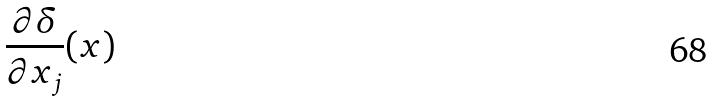Convert formula to latex. <formula><loc_0><loc_0><loc_500><loc_500>\frac { \partial \delta } { \partial x _ { j } } ( x )</formula> 